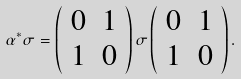Convert formula to latex. <formula><loc_0><loc_0><loc_500><loc_500>\alpha ^ { * } \sigma = \left ( \begin{array} { c c } 0 & 1 \\ 1 & 0 \end{array} \right ) \sigma \left ( \begin{array} { c c } 0 & 1 \\ 1 & 0 \end{array} \right ) .</formula> 